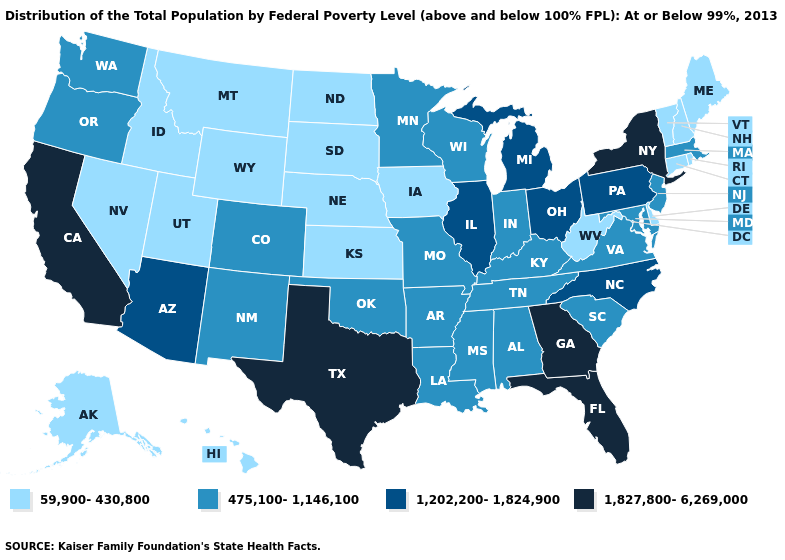Does the map have missing data?
Write a very short answer. No. Does Illinois have the highest value in the MidWest?
Short answer required. Yes. Does the first symbol in the legend represent the smallest category?
Write a very short answer. Yes. Which states have the highest value in the USA?
Short answer required. California, Florida, Georgia, New York, Texas. What is the highest value in the USA?
Be succinct. 1,827,800-6,269,000. Does Washington have the same value as Oklahoma?
Quick response, please. Yes. Does Illinois have the lowest value in the MidWest?
Give a very brief answer. No. What is the lowest value in the South?
Short answer required. 59,900-430,800. What is the value of Michigan?
Quick response, please. 1,202,200-1,824,900. Does New York have the lowest value in the Northeast?
Answer briefly. No. Does Kentucky have the same value as North Dakota?
Concise answer only. No. What is the value of New Mexico?
Give a very brief answer. 475,100-1,146,100. Which states hav the highest value in the MidWest?
Give a very brief answer. Illinois, Michigan, Ohio. What is the value of Tennessee?
Concise answer only. 475,100-1,146,100. Name the states that have a value in the range 59,900-430,800?
Short answer required. Alaska, Connecticut, Delaware, Hawaii, Idaho, Iowa, Kansas, Maine, Montana, Nebraska, Nevada, New Hampshire, North Dakota, Rhode Island, South Dakota, Utah, Vermont, West Virginia, Wyoming. 